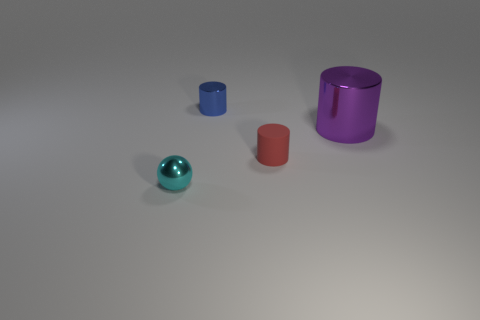There is a tiny thing that is to the left of the tiny red cylinder and in front of the small blue metal object; what is it made of?
Ensure brevity in your answer.  Metal. What is the material of the blue cylinder that is the same size as the red matte cylinder?
Offer a very short reply. Metal. Are there an equal number of red cylinders behind the small red object and cyan metallic objects that are behind the small metallic cylinder?
Give a very brief answer. Yes. There is a metallic object right of the small shiny thing that is behind the small shiny ball; how many objects are behind it?
Ensure brevity in your answer.  1. What size is the cyan thing that is the same material as the purple cylinder?
Ensure brevity in your answer.  Small. Is the number of things behind the tiny metal sphere greater than the number of tiny shiny objects?
Offer a very short reply. Yes. What is the small object on the left side of the small metallic object behind the shiny object in front of the large shiny object made of?
Provide a succinct answer. Metal. Is the blue cylinder made of the same material as the small thing that is to the right of the blue metallic thing?
Keep it short and to the point. No. What material is the other small thing that is the same shape as the tiny blue metallic object?
Make the answer very short. Rubber. Is there any other thing that is made of the same material as the red thing?
Give a very brief answer. No. 